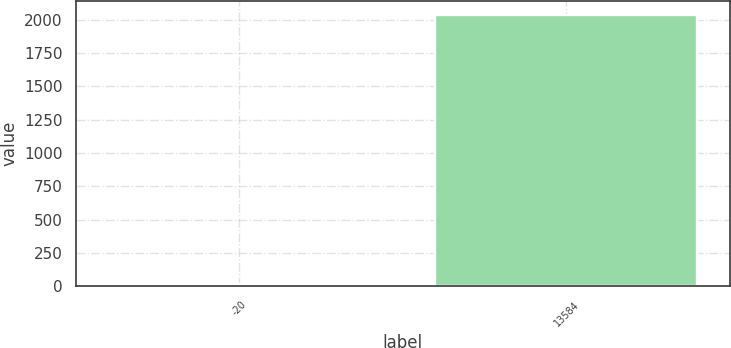<chart> <loc_0><loc_0><loc_500><loc_500><bar_chart><fcel>-20<fcel>13584<nl><fcel>20<fcel>2037.6<nl></chart> 